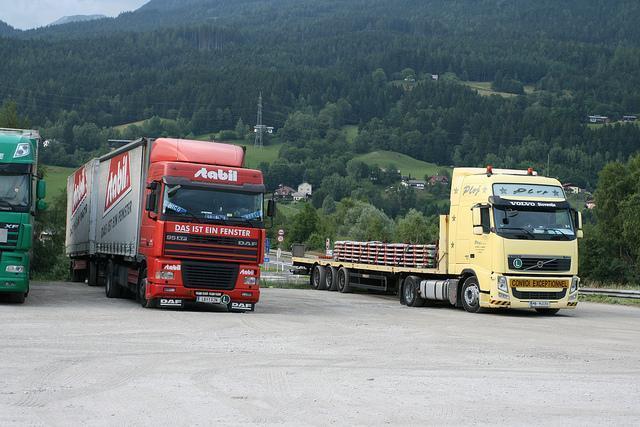How many trucks are in the picture?
Give a very brief answer. 3. How many wheels are visible in this picture?
Give a very brief answer. 9. How many trucks are on the street?
Give a very brief answer. 3. How many vehicles are there?
Give a very brief answer. 3. How many trucks are visible?
Give a very brief answer. 3. 